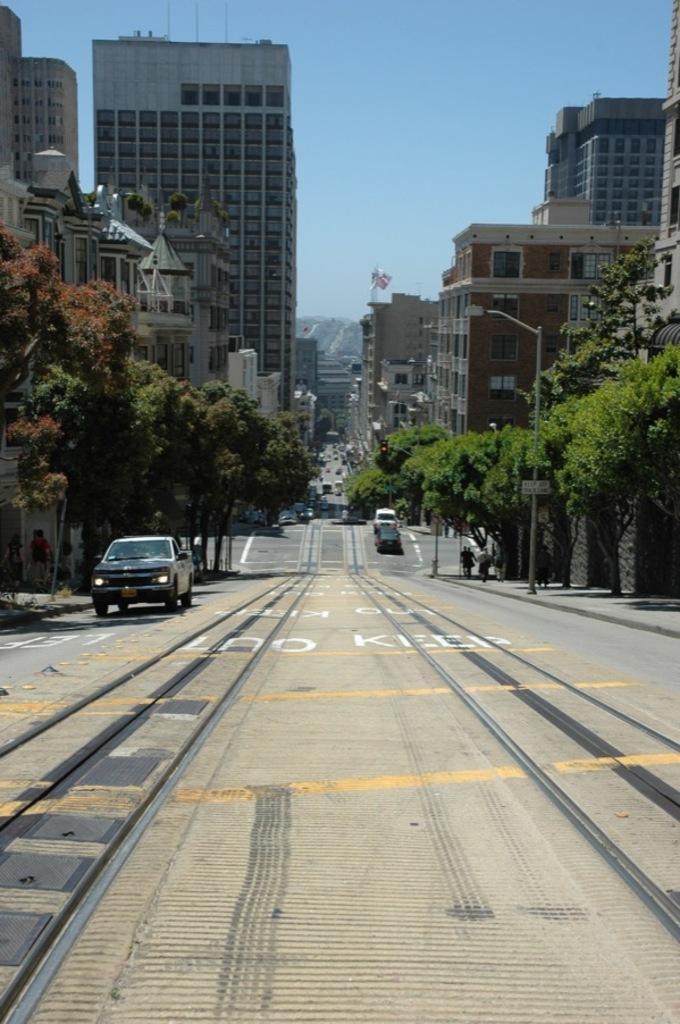Please provide a concise description of this image. In this picture there are buildings and trees and poles and there are vehicles on the road and there are group of people walking on the footpath. At the top there is sky. At the bottom there is a road. 